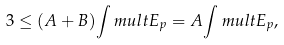Convert formula to latex. <formula><loc_0><loc_0><loc_500><loc_500>3 \leq ( A + B ) { \int m u l t } E _ { p } = A { \int m u l t } E _ { p } ,</formula> 